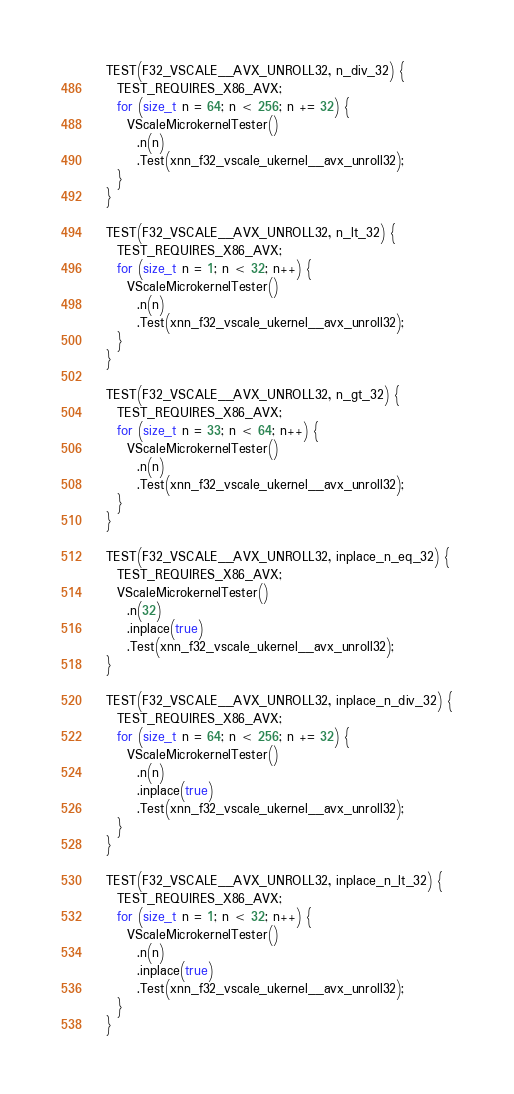Convert code to text. <code><loc_0><loc_0><loc_500><loc_500><_C++_>  TEST(F32_VSCALE__AVX_UNROLL32, n_div_32) {
    TEST_REQUIRES_X86_AVX;
    for (size_t n = 64; n < 256; n += 32) {
      VScaleMicrokernelTester()
        .n(n)
        .Test(xnn_f32_vscale_ukernel__avx_unroll32);
    }
  }

  TEST(F32_VSCALE__AVX_UNROLL32, n_lt_32) {
    TEST_REQUIRES_X86_AVX;
    for (size_t n = 1; n < 32; n++) {
      VScaleMicrokernelTester()
        .n(n)
        .Test(xnn_f32_vscale_ukernel__avx_unroll32);
    }
  }

  TEST(F32_VSCALE__AVX_UNROLL32, n_gt_32) {
    TEST_REQUIRES_X86_AVX;
    for (size_t n = 33; n < 64; n++) {
      VScaleMicrokernelTester()
        .n(n)
        .Test(xnn_f32_vscale_ukernel__avx_unroll32);
    }
  }

  TEST(F32_VSCALE__AVX_UNROLL32, inplace_n_eq_32) {
    TEST_REQUIRES_X86_AVX;
    VScaleMicrokernelTester()
      .n(32)
      .inplace(true)
      .Test(xnn_f32_vscale_ukernel__avx_unroll32);
  }

  TEST(F32_VSCALE__AVX_UNROLL32, inplace_n_div_32) {
    TEST_REQUIRES_X86_AVX;
    for (size_t n = 64; n < 256; n += 32) {
      VScaleMicrokernelTester()
        .n(n)
        .inplace(true)
        .Test(xnn_f32_vscale_ukernel__avx_unroll32);
    }
  }

  TEST(F32_VSCALE__AVX_UNROLL32, inplace_n_lt_32) {
    TEST_REQUIRES_X86_AVX;
    for (size_t n = 1; n < 32; n++) {
      VScaleMicrokernelTester()
        .n(n)
        .inplace(true)
        .Test(xnn_f32_vscale_ukernel__avx_unroll32);
    }
  }
</code> 